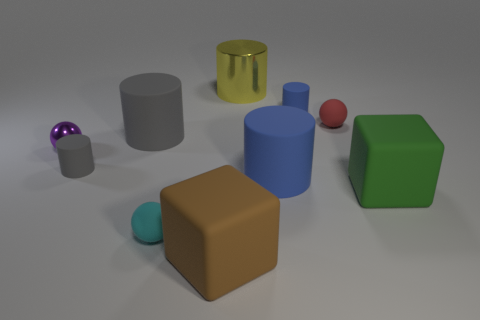Are there the same number of tiny red balls behind the tiny red object and small cyan balls that are to the right of the small purple thing?
Provide a succinct answer. No. The shiny thing left of the big cube that is left of the small matte cylinder that is right of the brown rubber block is what color?
Keep it short and to the point. Purple. How many matte things are left of the big brown matte object and in front of the green rubber thing?
Give a very brief answer. 1. There is a big cylinder in front of the big gray cylinder; is its color the same as the matte cylinder behind the red matte object?
Your response must be concise. Yes. What is the size of the cyan thing that is the same shape as the tiny purple object?
Make the answer very short. Small. There is a small red sphere; are there any shiny things in front of it?
Make the answer very short. Yes. Are there an equal number of small cyan balls that are to the right of the tiny blue cylinder and large yellow balls?
Give a very brief answer. Yes. Are there any brown objects in front of the blue matte cylinder behind the red thing that is right of the large metallic object?
Your answer should be very brief. Yes. What material is the yellow cylinder?
Provide a succinct answer. Metal. What number of other objects are there of the same shape as the large yellow thing?
Provide a succinct answer. 4. 